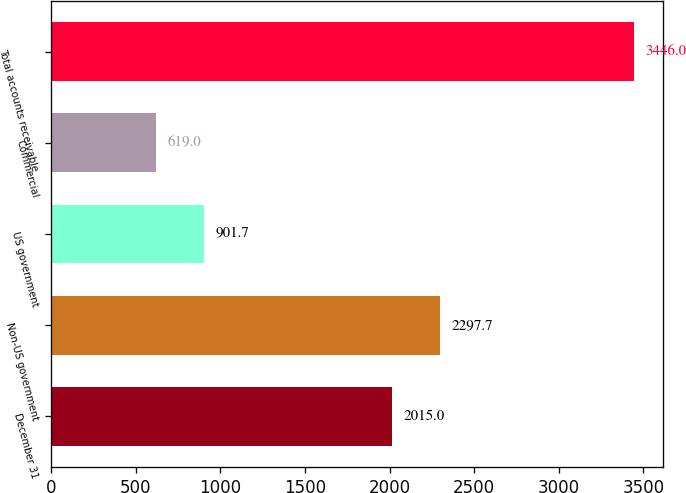<chart> <loc_0><loc_0><loc_500><loc_500><bar_chart><fcel>December 31<fcel>Non-US government<fcel>US government<fcel>Commercial<fcel>Total accounts receivable<nl><fcel>2015<fcel>2297.7<fcel>901.7<fcel>619<fcel>3446<nl></chart> 